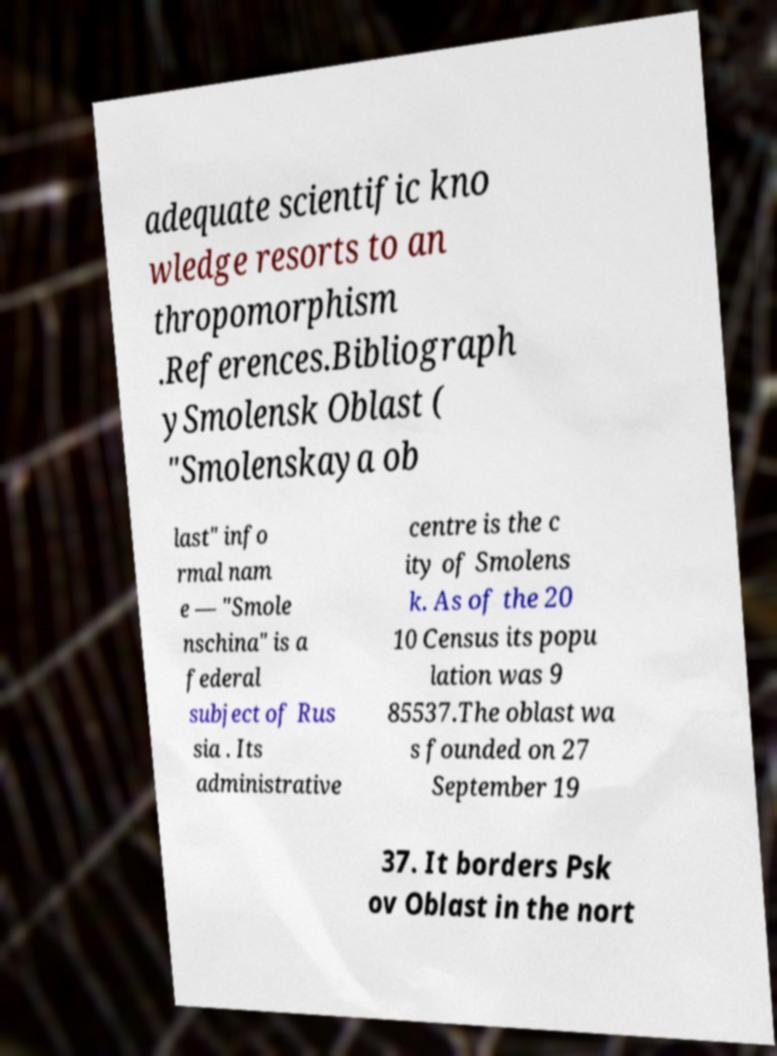Can you read and provide the text displayed in the image?This photo seems to have some interesting text. Can you extract and type it out for me? adequate scientific kno wledge resorts to an thropomorphism .References.Bibliograph ySmolensk Oblast ( "Smolenskaya ob last" info rmal nam e — "Smole nschina" is a federal subject of Rus sia . Its administrative centre is the c ity of Smolens k. As of the 20 10 Census its popu lation was 9 85537.The oblast wa s founded on 27 September 19 37. It borders Psk ov Oblast in the nort 